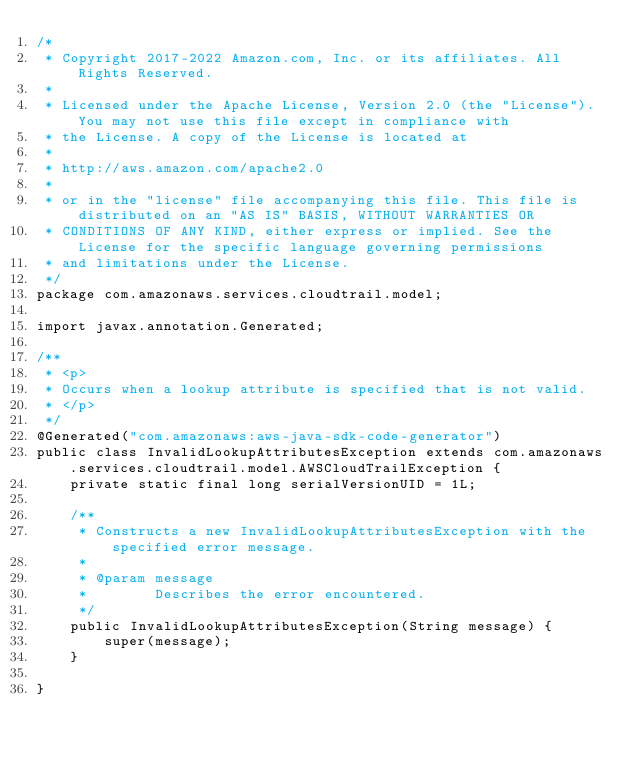Convert code to text. <code><loc_0><loc_0><loc_500><loc_500><_Java_>/*
 * Copyright 2017-2022 Amazon.com, Inc. or its affiliates. All Rights Reserved.
 * 
 * Licensed under the Apache License, Version 2.0 (the "License"). You may not use this file except in compliance with
 * the License. A copy of the License is located at
 * 
 * http://aws.amazon.com/apache2.0
 * 
 * or in the "license" file accompanying this file. This file is distributed on an "AS IS" BASIS, WITHOUT WARRANTIES OR
 * CONDITIONS OF ANY KIND, either express or implied. See the License for the specific language governing permissions
 * and limitations under the License.
 */
package com.amazonaws.services.cloudtrail.model;

import javax.annotation.Generated;

/**
 * <p>
 * Occurs when a lookup attribute is specified that is not valid.
 * </p>
 */
@Generated("com.amazonaws:aws-java-sdk-code-generator")
public class InvalidLookupAttributesException extends com.amazonaws.services.cloudtrail.model.AWSCloudTrailException {
    private static final long serialVersionUID = 1L;

    /**
     * Constructs a new InvalidLookupAttributesException with the specified error message.
     *
     * @param message
     *        Describes the error encountered.
     */
    public InvalidLookupAttributesException(String message) {
        super(message);
    }

}
</code> 